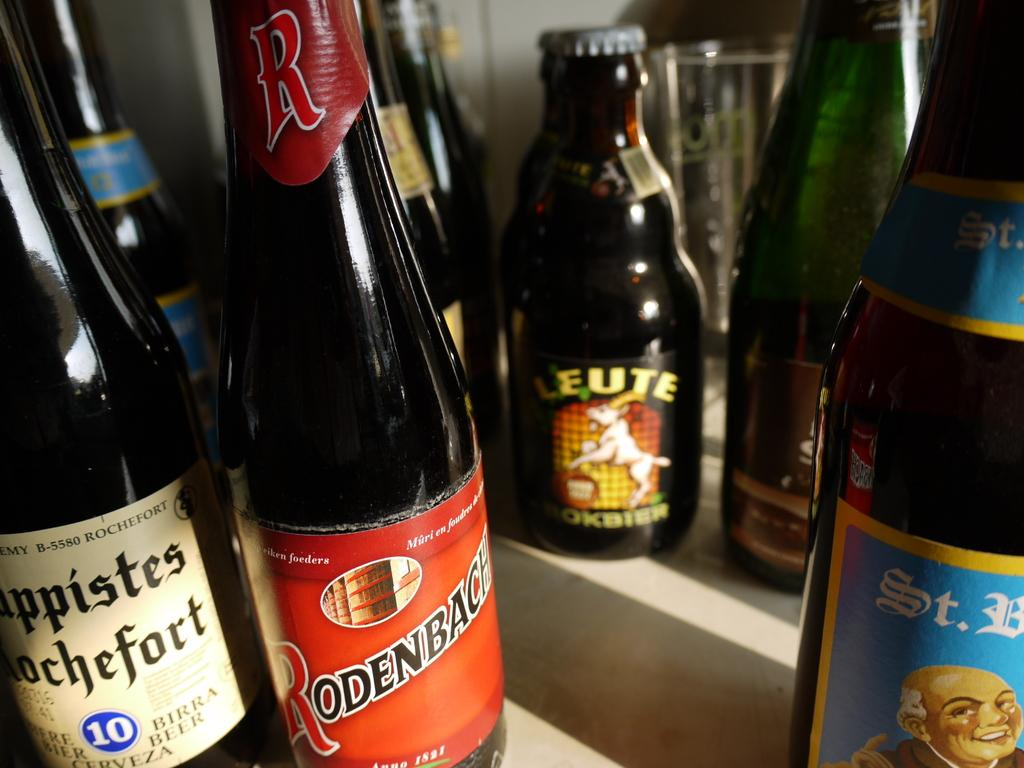<image>
Offer a succinct explanation of the picture presented. An alcohol bottle with the number 10 on it. 